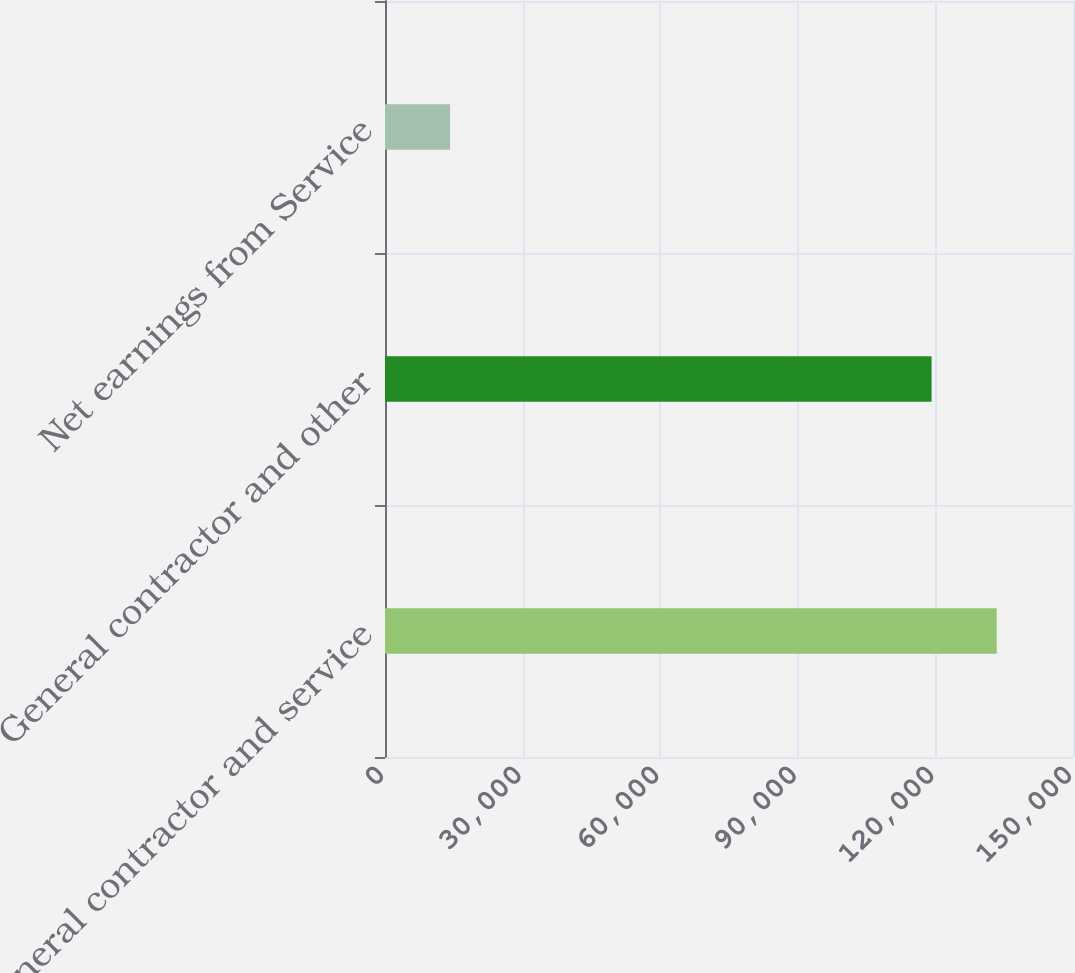<chart> <loc_0><loc_0><loc_500><loc_500><bar_chart><fcel>General contractor and service<fcel>General contractor and other<fcel>Net earnings from Service<nl><fcel>133367<fcel>119170<fcel>14197<nl></chart> 